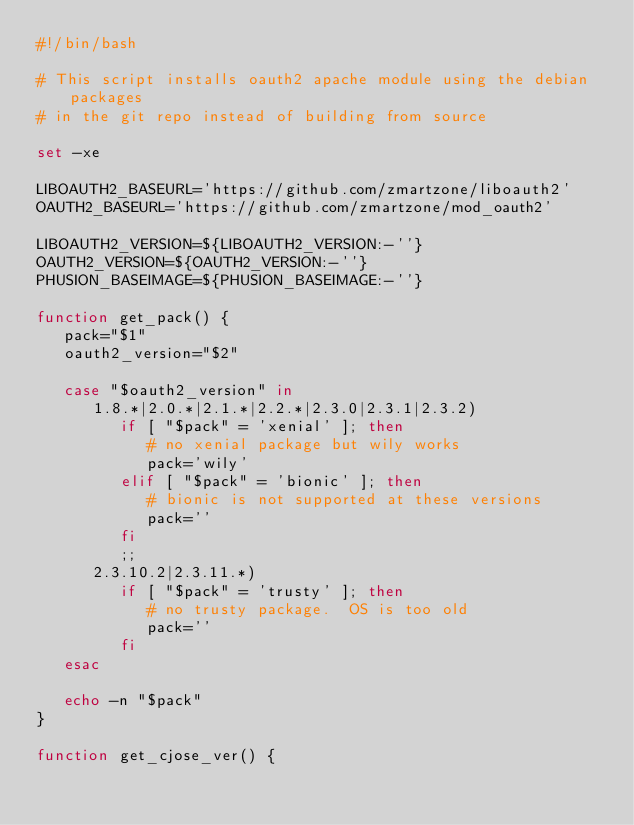Convert code to text. <code><loc_0><loc_0><loc_500><loc_500><_Bash_>#!/bin/bash

# This script installs oauth2 apache module using the debian packages
# in the git repo instead of building from source

set -xe

LIBOAUTH2_BASEURL='https://github.com/zmartzone/liboauth2'
OAUTH2_BASEURL='https://github.com/zmartzone/mod_oauth2'

LIBOAUTH2_VERSION=${LIBOAUTH2_VERSION:-''}
OAUTH2_VERSION=${OAUTH2_VERSION:-''}
PHUSION_BASEIMAGE=${PHUSION_BASEIMAGE:-''}

function get_pack() {
   pack="$1"
   oauth2_version="$2"

   case "$oauth2_version" in
      1.8.*|2.0.*|2.1.*|2.2.*|2.3.0|2.3.1|2.3.2)
         if [ "$pack" = 'xenial' ]; then
            # no xenial package but wily works
            pack='wily'
         elif [ "$pack" = 'bionic' ]; then
            # bionic is not supported at these versions
            pack=''
         fi
         ;;
      2.3.10.2|2.3.11.*)
         if [ "$pack" = 'trusty' ]; then
            # no trusty package.  OS is too old
            pack=''
         fi
   esac

   echo -n "$pack"
}

function get_cjose_ver() {</code> 